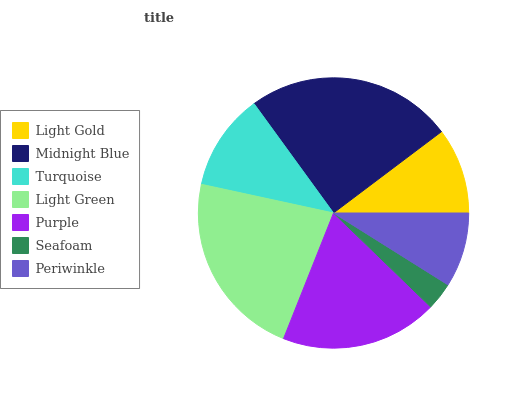Is Seafoam the minimum?
Answer yes or no. Yes. Is Midnight Blue the maximum?
Answer yes or no. Yes. Is Turquoise the minimum?
Answer yes or no. No. Is Turquoise the maximum?
Answer yes or no. No. Is Midnight Blue greater than Turquoise?
Answer yes or no. Yes. Is Turquoise less than Midnight Blue?
Answer yes or no. Yes. Is Turquoise greater than Midnight Blue?
Answer yes or no. No. Is Midnight Blue less than Turquoise?
Answer yes or no. No. Is Turquoise the high median?
Answer yes or no. Yes. Is Turquoise the low median?
Answer yes or no. Yes. Is Light Gold the high median?
Answer yes or no. No. Is Light Gold the low median?
Answer yes or no. No. 